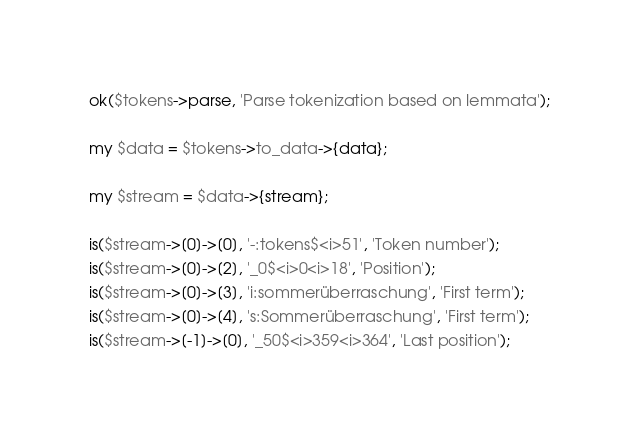<code> <loc_0><loc_0><loc_500><loc_500><_Perl_>
ok($tokens->parse, 'Parse tokenization based on lemmata');

my $data = $tokens->to_data->{data};

my $stream = $data->{stream};

is($stream->[0]->[0], '-:tokens$<i>51', 'Token number');
is($stream->[0]->[2], '_0$<i>0<i>18', 'Position');
is($stream->[0]->[3], 'i:sommerüberraschung', 'First term');
is($stream->[0]->[4], 's:Sommerüberraschung', 'First term');
is($stream->[-1]->[0], '_50$<i>359<i>364', 'Last position');</code> 